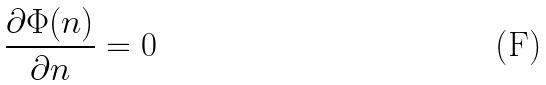<formula> <loc_0><loc_0><loc_500><loc_500>\frac { \partial \Phi ( n ) } { \partial n } = 0</formula> 